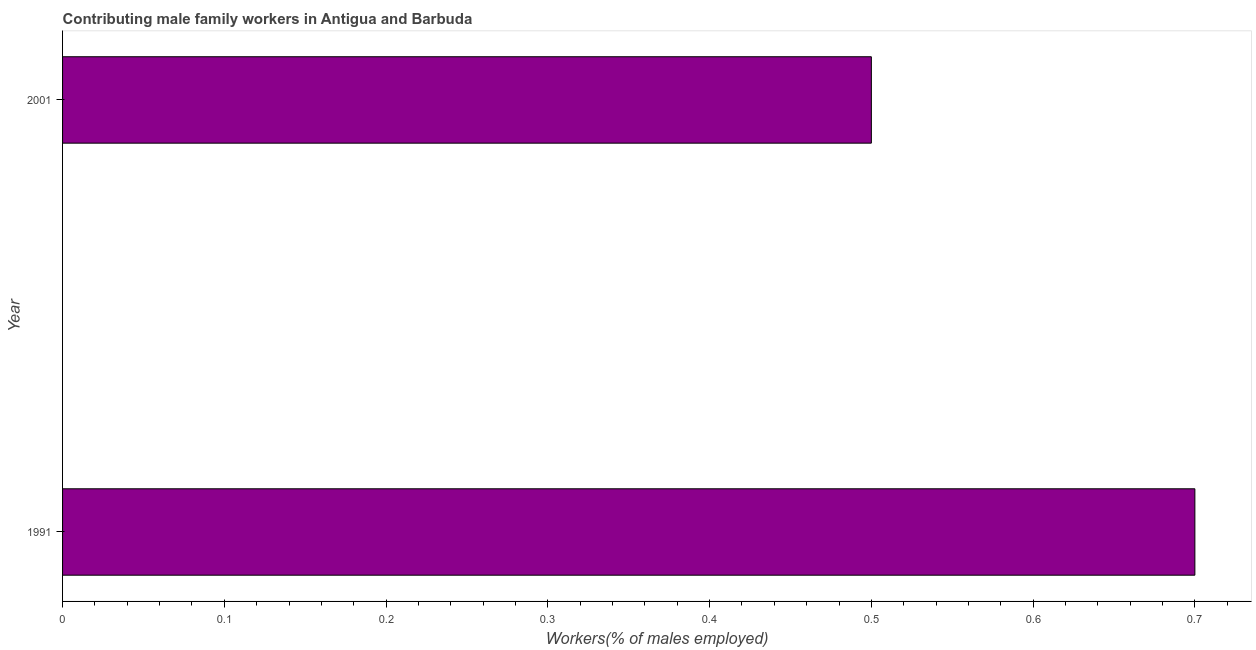Does the graph contain any zero values?
Keep it short and to the point. No. What is the title of the graph?
Your answer should be compact. Contributing male family workers in Antigua and Barbuda. What is the label or title of the X-axis?
Offer a terse response. Workers(% of males employed). What is the contributing male family workers in 1991?
Keep it short and to the point. 0.7. Across all years, what is the maximum contributing male family workers?
Your answer should be compact. 0.7. In which year was the contributing male family workers maximum?
Provide a short and direct response. 1991. In which year was the contributing male family workers minimum?
Make the answer very short. 2001. What is the sum of the contributing male family workers?
Make the answer very short. 1.2. What is the difference between the contributing male family workers in 1991 and 2001?
Offer a very short reply. 0.2. What is the average contributing male family workers per year?
Offer a terse response. 0.6. What is the median contributing male family workers?
Give a very brief answer. 0.6. In how many years, is the contributing male family workers greater than 0.66 %?
Your answer should be compact. 1. In how many years, is the contributing male family workers greater than the average contributing male family workers taken over all years?
Keep it short and to the point. 1. How many bars are there?
Provide a succinct answer. 2. Are all the bars in the graph horizontal?
Offer a very short reply. Yes. How many years are there in the graph?
Make the answer very short. 2. What is the Workers(% of males employed) of 1991?
Your response must be concise. 0.7. 